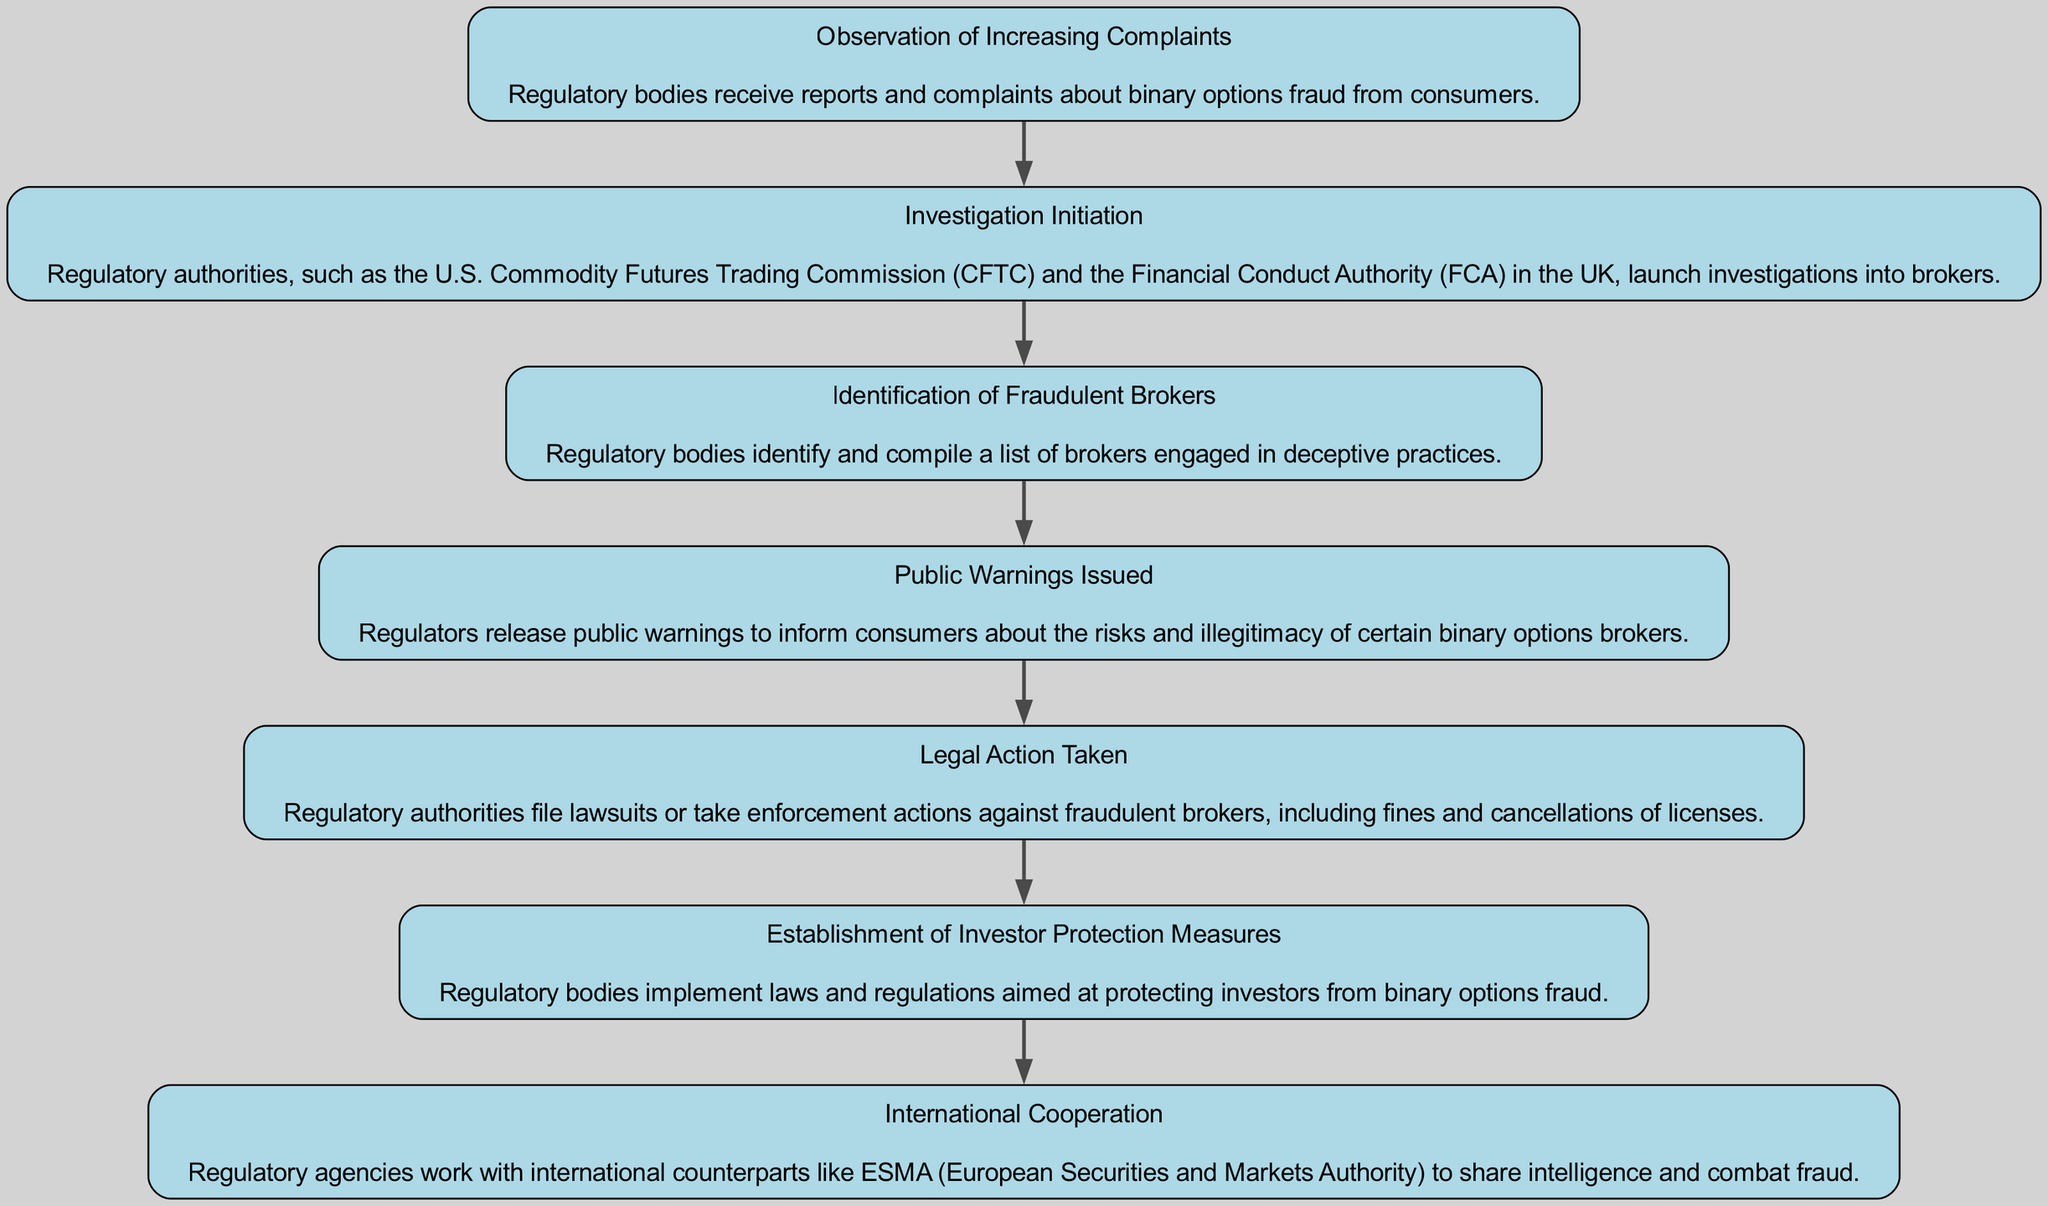What is the first step taken by regulatory bodies? The first step listed in the diagram is "Observation of Increasing Complaints", which indicates that regulatory bodies begin their process by receiving reports and complaints from consumers regarding binary options fraud.
Answer: Observation of Increasing Complaints How many steps are shown in the flow chart? The diagram lists a total of seven distinct steps that regulatory bodies take in response to binary options fraud, which can be counted within the flow.
Answer: 7 What step follows "Public Warnings Issued"? After "Public Warnings Issued", the next step in the diagram is "Legal Action Taken", showing that regulators take further actions after informing the public.
Answer: Legal Action Taken Which regulatory body is mentioned in the investigation initiation step? The diagram specifically mentions the "U.S. Commodity Futures Trading Commission (CFTC)" as one of the regulatory authorities that initiate investigations into brokers.
Answer: U.S. Commodity Futures Trading Commission (CFTC) What is the purpose of the "Establishment of Investor Protection Measures"? The purpose of this step is to implement laws and regulations that aim at safeguarding investors from binary options fraud, making it a protective action by regulatory bodies.
Answer: Protecting investors What is a common action taken in response to fraudulent brokers? A typical action mentioned in the diagram is "Legal Action Taken," which includes filing lawsuits or taking enforcement actions against those brokers found engaging in fraudulent activities.
Answer: Legal Action Taken What do regulatory bodies issue to inform consumers? Regulatory bodies release "Public Warnings" to inform consumers about the risks and the illegitimacy of certain binary options brokers, which is an important communication step in the process.
Answer: Public Warnings How do regulatory agencies enhance their fraud combat efforts? Regulatory agencies enhance their efforts by engaging in "International Cooperation," which allows them to work with international counterparts to share intelligence relating to fraud in binary options trading.
Answer: International Cooperation 